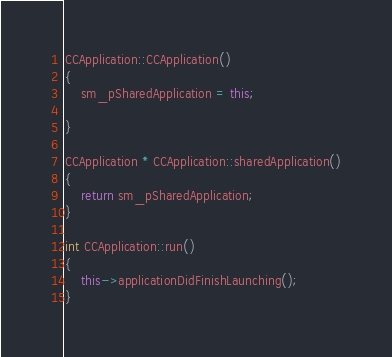<code> <loc_0><loc_0><loc_500><loc_500><_C++_>CCApplication::CCApplication()
{
    sm_pSharedApplication = this;

}

CCApplication * CCApplication::sharedApplication()
{
    return sm_pSharedApplication;
}

int CCApplication::run()
{
    this->applicationDidFinishLaunching();
}
</code> 